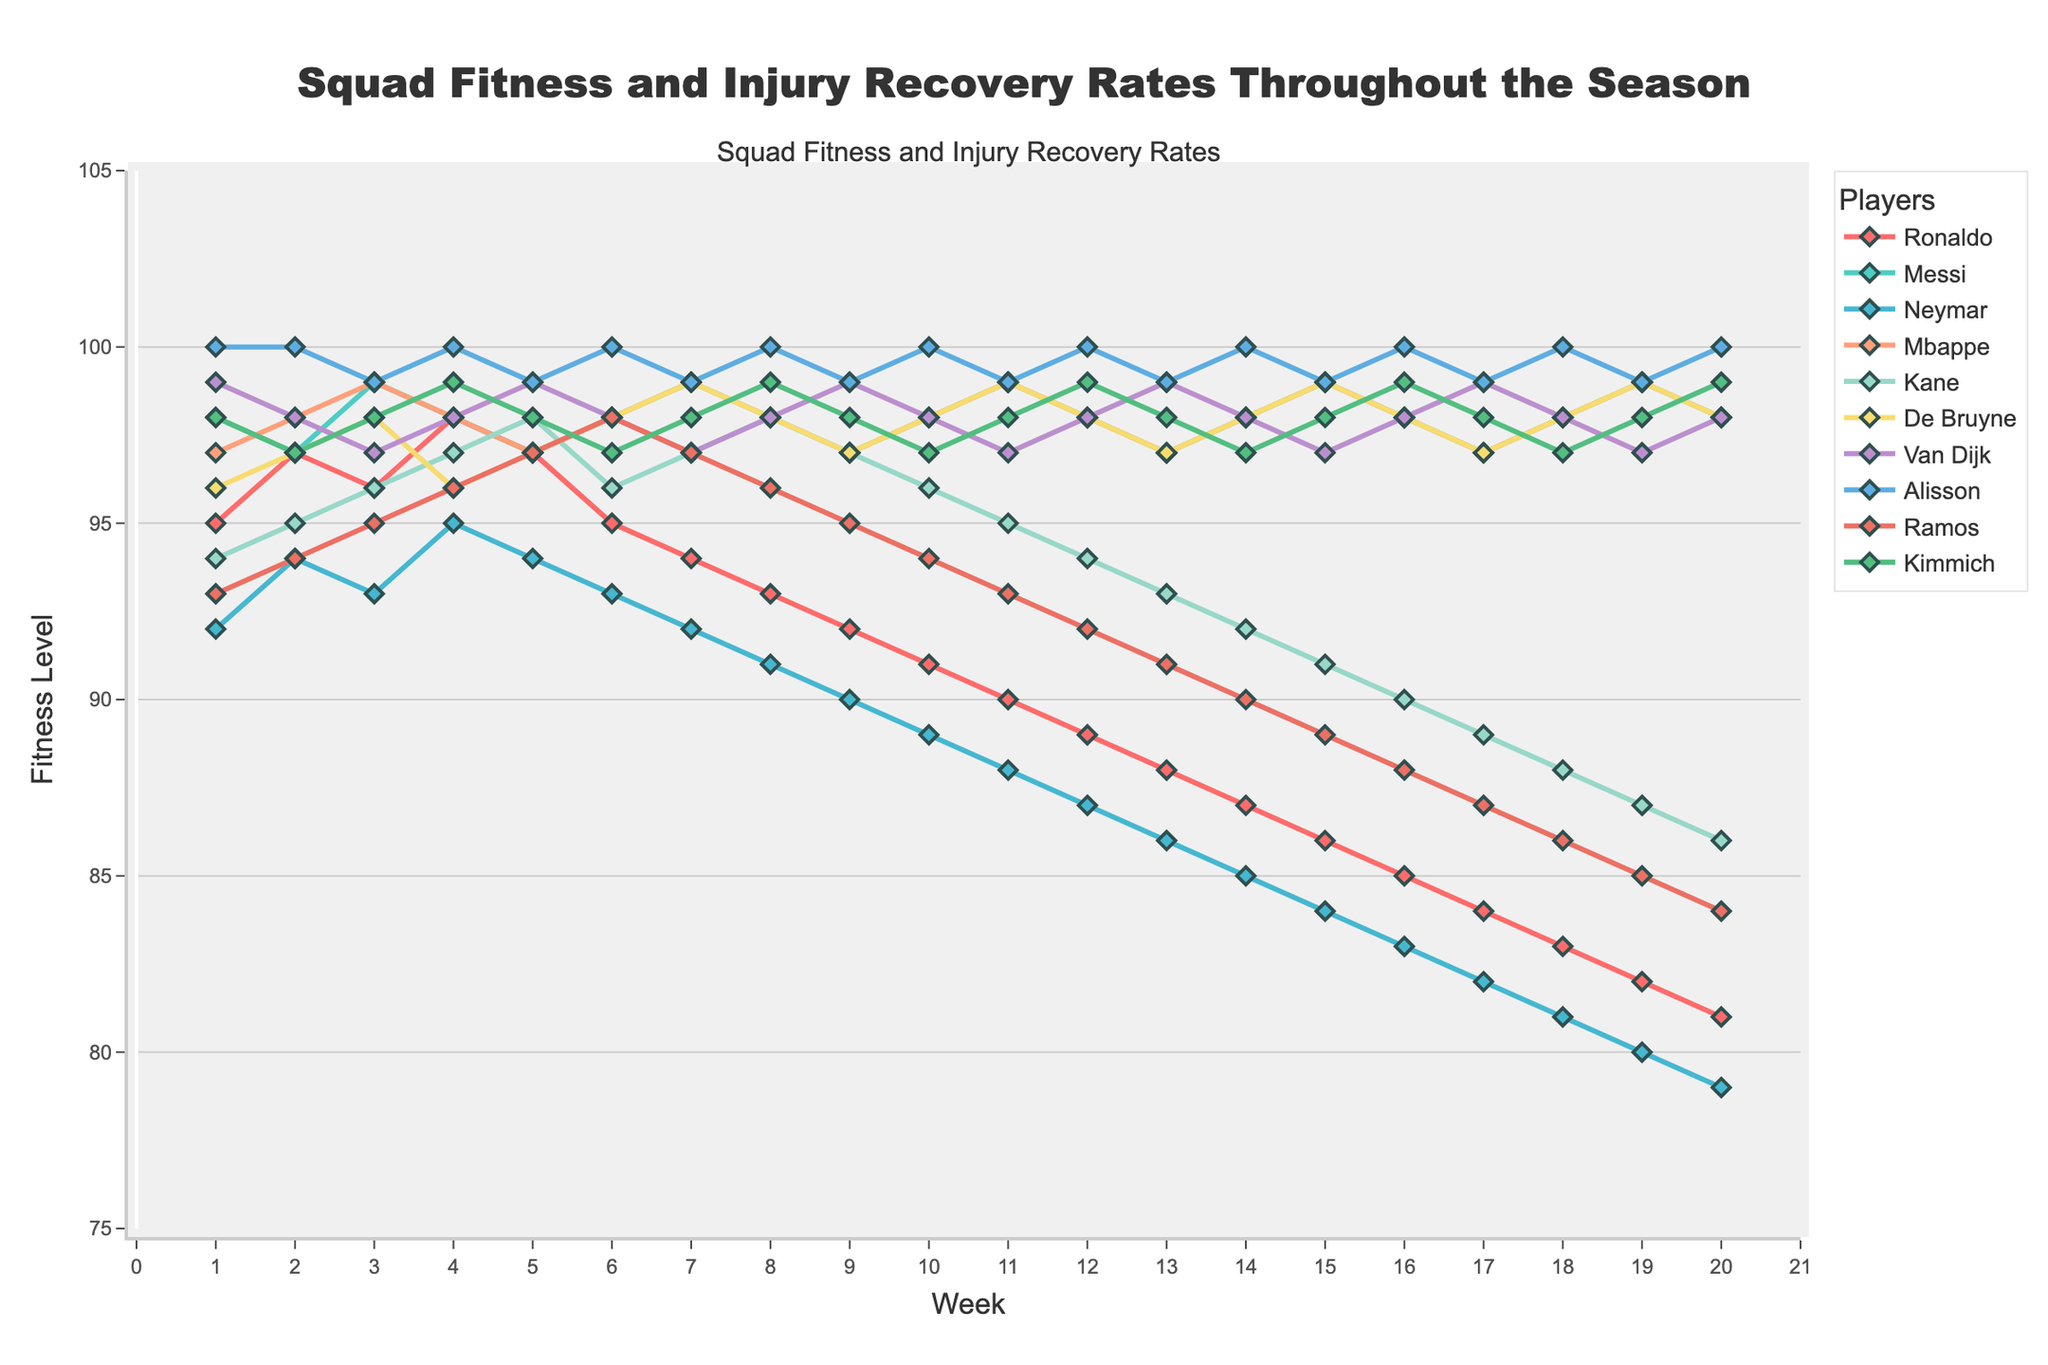What's the trend for Neymar's fitness level throughout the season? Neymar's fitness level starts at 92 in Week 1 and decreases over time, reaching 79 by Week 20.
Answer: Decreasing Who maintained the highest fitness level consistently throughout the season? Alisson maintained a fitness level of 100 for every week throughout the entire season.
Answer: Alisson Who experienced the most significant drop in fitness level from Week 1 to Week 20? Neymar's fitness level drops from 92 in Week 1 to 79 in Week 20, which is a decrease of 13 points.
Answer: Neymar Compare the fitness levels of Ronaldo and Messi at Week 10. Who is fitter and by how much? At Week 10, Ronaldo's fitness level is 91, while Messi's is 98. Messi is fitter than Ronaldo by 7 points.
Answer: Messi by 7 points Between Week 1 and Week 10, how many players' fitness levels declined continuously? Checking the plot for each player, Neymar, Kimmich, Ramos, and Ronaldo show a continuous decline in fitness levels week-by-week from Week 1 to Week 10.
Answer: 4 players What's the average fitness level of all players at Week 5? Sum the fitness levels of all players at Week 5: 97 + 97 + 94 + 97 + 98 + 97 + 99 + 99 + 97 + 98 = 973. Dividing by 10 gives an average fitness level of 97.3.
Answer: 97.3 Which player showed an improvement in their fitness level by Week 4 compared to Week 2? Comparing Week 4 to Week 2, Ronaldo (97 to 98), Mbappe (98 to 98), Kimmich (97 to 99) all show improvements.
Answer: Ronaldo, Mbappe, Kimmich What is the maximum fitness level attained by De Bruyne throughout the entire season? Observing the plot, the highest fitness level De Bruyne reaches is 99.
Answer: 99 Who has the most stable fitness level (least fluctuations) throughout the season? Alisson has the most stable fitness, consistently at 100 without any fluctuations.
Answer: Alisson Compare the fitness recovery trends of Ramos and Van Dijk between Week 5 and Week 10. Ramos's fitness declines from 97 to 94, while Van Dijk's fitness moves from 98 to 98. Van Dijk shows no decline compared to Ramos.
Answer: Van Dijk (no decline) 